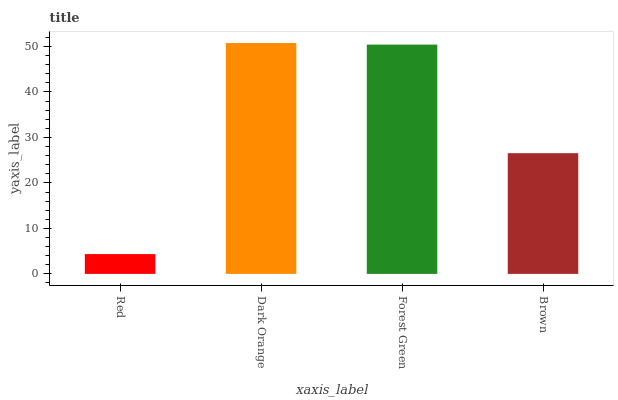Is Red the minimum?
Answer yes or no. Yes. Is Dark Orange the maximum?
Answer yes or no. Yes. Is Forest Green the minimum?
Answer yes or no. No. Is Forest Green the maximum?
Answer yes or no. No. Is Dark Orange greater than Forest Green?
Answer yes or no. Yes. Is Forest Green less than Dark Orange?
Answer yes or no. Yes. Is Forest Green greater than Dark Orange?
Answer yes or no. No. Is Dark Orange less than Forest Green?
Answer yes or no. No. Is Forest Green the high median?
Answer yes or no. Yes. Is Brown the low median?
Answer yes or no. Yes. Is Dark Orange the high median?
Answer yes or no. No. Is Dark Orange the low median?
Answer yes or no. No. 